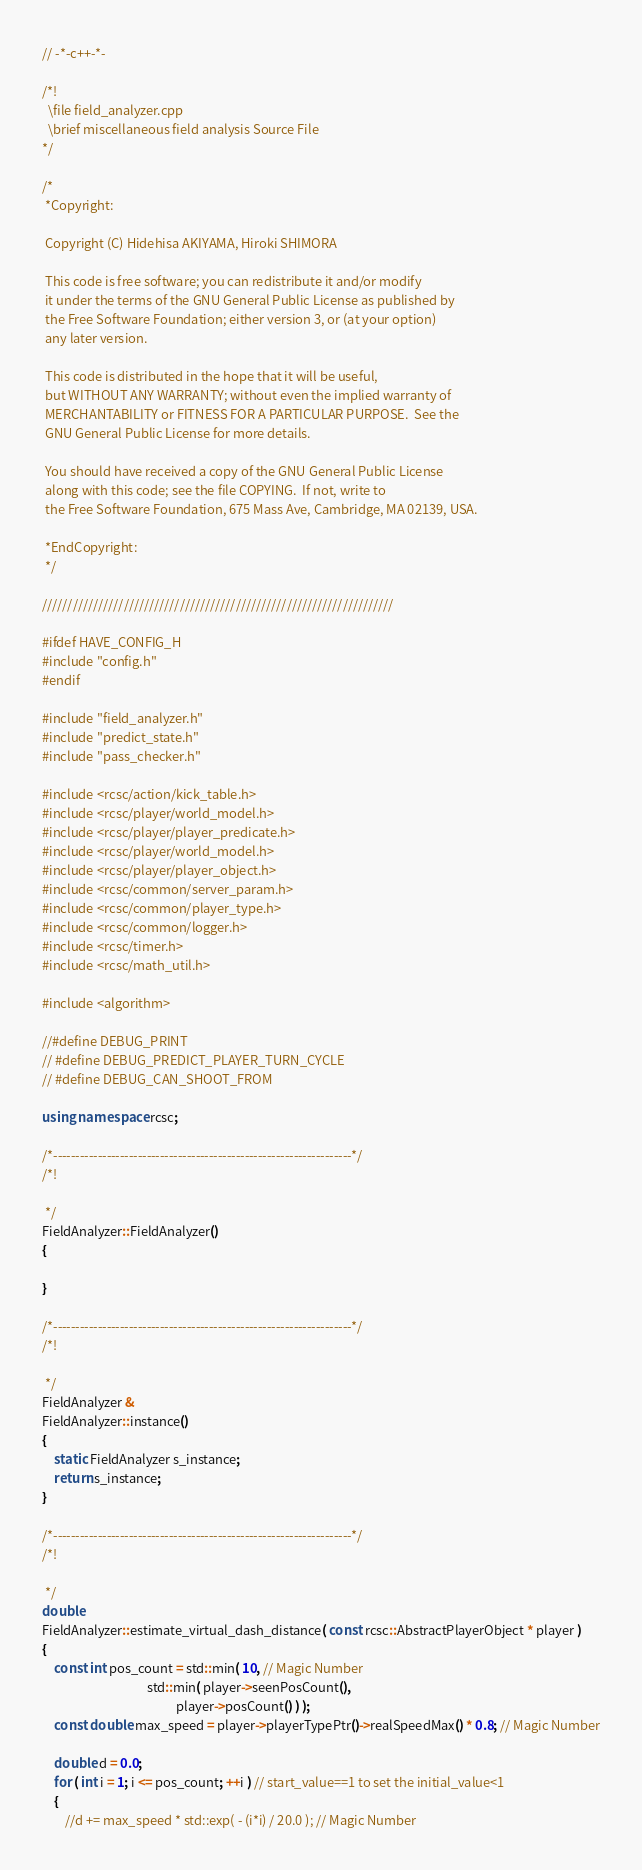<code> <loc_0><loc_0><loc_500><loc_500><_C++_>// -*-c++-*-

/*!
  \file field_analyzer.cpp
  \brief miscellaneous field analysis Source File
*/

/*
 *Copyright:

 Copyright (C) Hidehisa AKIYAMA, Hiroki SHIMORA

 This code is free software; you can redistribute it and/or modify
 it under the terms of the GNU General Public License as published by
 the Free Software Foundation; either version 3, or (at your option)
 any later version.

 This code is distributed in the hope that it will be useful,
 but WITHOUT ANY WARRANTY; without even the implied warranty of
 MERCHANTABILITY or FITNESS FOR A PARTICULAR PURPOSE.  See the
 GNU General Public License for more details.

 You should have received a copy of the GNU General Public License
 along with this code; see the file COPYING.  If not, write to
 the Free Software Foundation, 675 Mass Ave, Cambridge, MA 02139, USA.

 *EndCopyright:
 */

/////////////////////////////////////////////////////////////////////

#ifdef HAVE_CONFIG_H
#include "config.h"
#endif

#include "field_analyzer.h"
#include "predict_state.h"
#include "pass_checker.h"

#include <rcsc/action/kick_table.h>
#include <rcsc/player/world_model.h>
#include <rcsc/player/player_predicate.h>
#include <rcsc/player/world_model.h>
#include <rcsc/player/player_object.h>
#include <rcsc/common/server_param.h>
#include <rcsc/common/player_type.h>
#include <rcsc/common/logger.h>
#include <rcsc/timer.h>
#include <rcsc/math_util.h>

#include <algorithm>

//#define DEBUG_PRINT
// #define DEBUG_PREDICT_PLAYER_TURN_CYCLE
// #define DEBUG_CAN_SHOOT_FROM

using namespace rcsc;

/*-------------------------------------------------------------------*/
/*!

 */
FieldAnalyzer::FieldAnalyzer()
{

}

/*-------------------------------------------------------------------*/
/*!

 */
FieldAnalyzer &
FieldAnalyzer::instance()
{
    static FieldAnalyzer s_instance;
    return s_instance;
}

/*-------------------------------------------------------------------*/
/*!

 */
double
FieldAnalyzer::estimate_virtual_dash_distance( const rcsc::AbstractPlayerObject * player )
{
    const int pos_count = std::min( 10, // Magic Number
                                    std::min( player->seenPosCount(),
                                              player->posCount() ) );
    const double max_speed = player->playerTypePtr()->realSpeedMax() * 0.8; // Magic Number

    double d = 0.0;
    for ( int i = 1; i <= pos_count; ++i ) // start_value==1 to set the initial_value<1
    {
        //d += max_speed * std::exp( - (i*i) / 20.0 ); // Magic Number</code> 